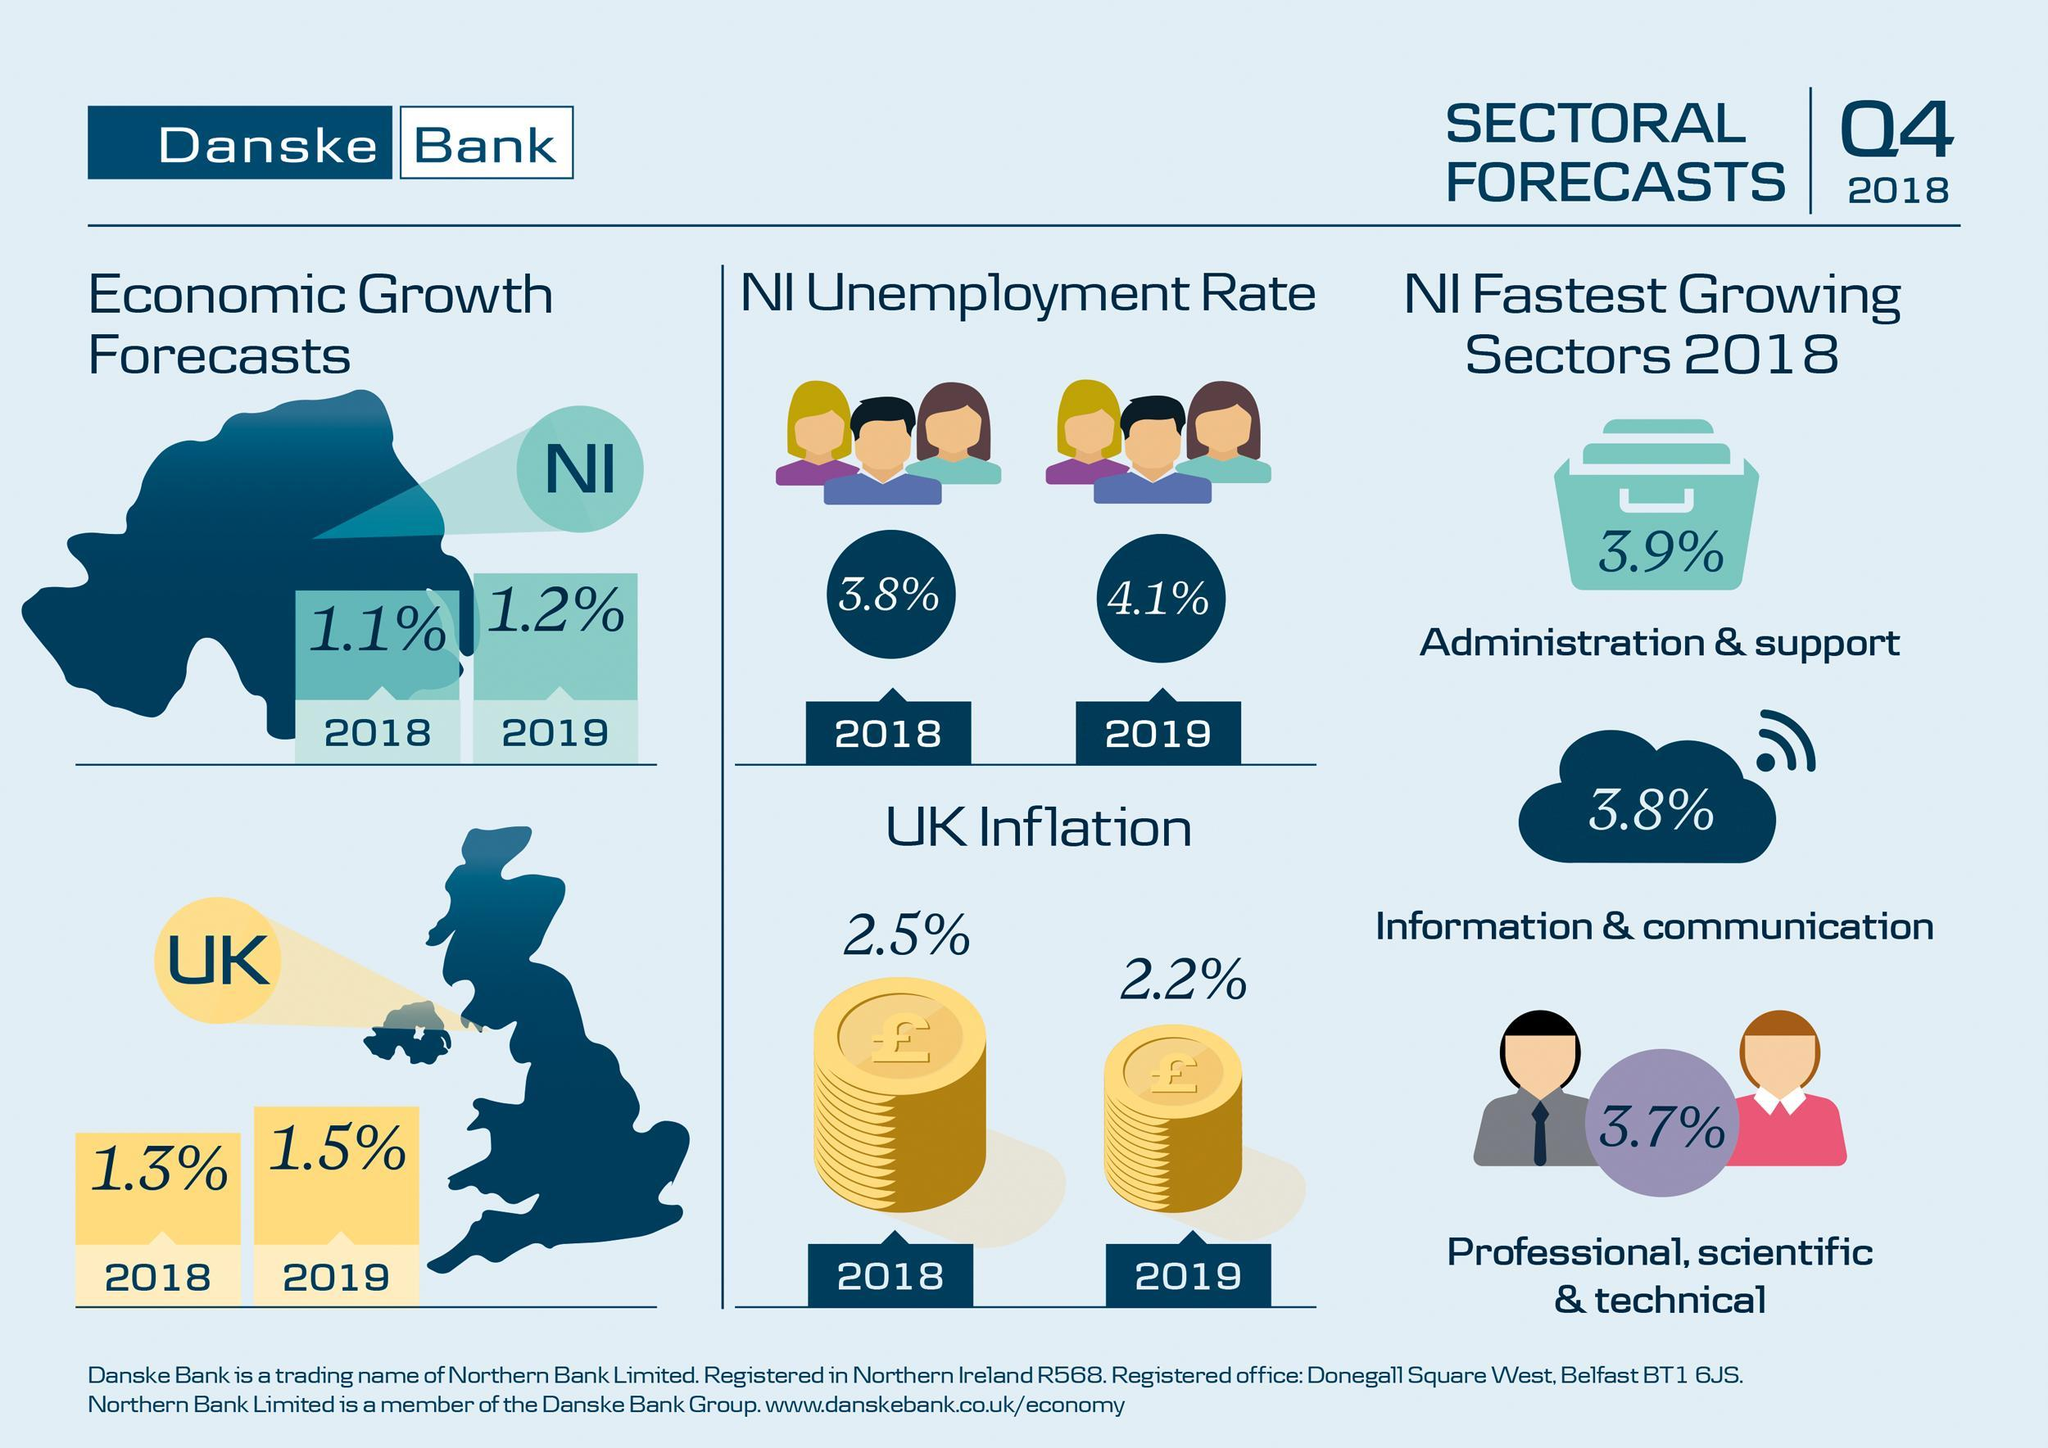What is the estimated unemployment rate in Northern Ireland in 2019?
Answer the question with a short phrase. 4.1% What is the inflation rate in UK in 2018? 2.5% Which sector in the Northern Ireland has shown a growth rate of 3.8% in 2018? Information & communication What is the percentage growth rate in the administration & support sector of Northern Ireland in 2018? 3.9% What is the estimated economic growth rate of UK in 2019? 1.5% What is the economic growth rate of Northern Ireland in 2018? 1.1% 